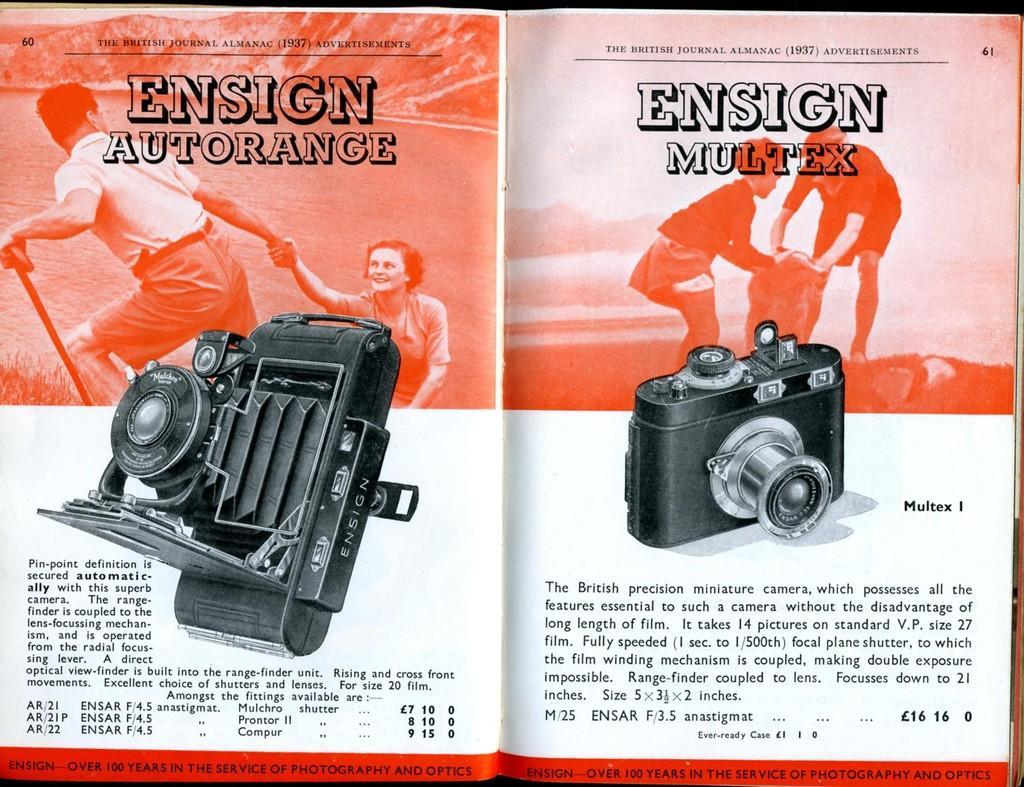How would you summarize this image in a sentence or two? In this picture we can see depictions and some information on the papers. 